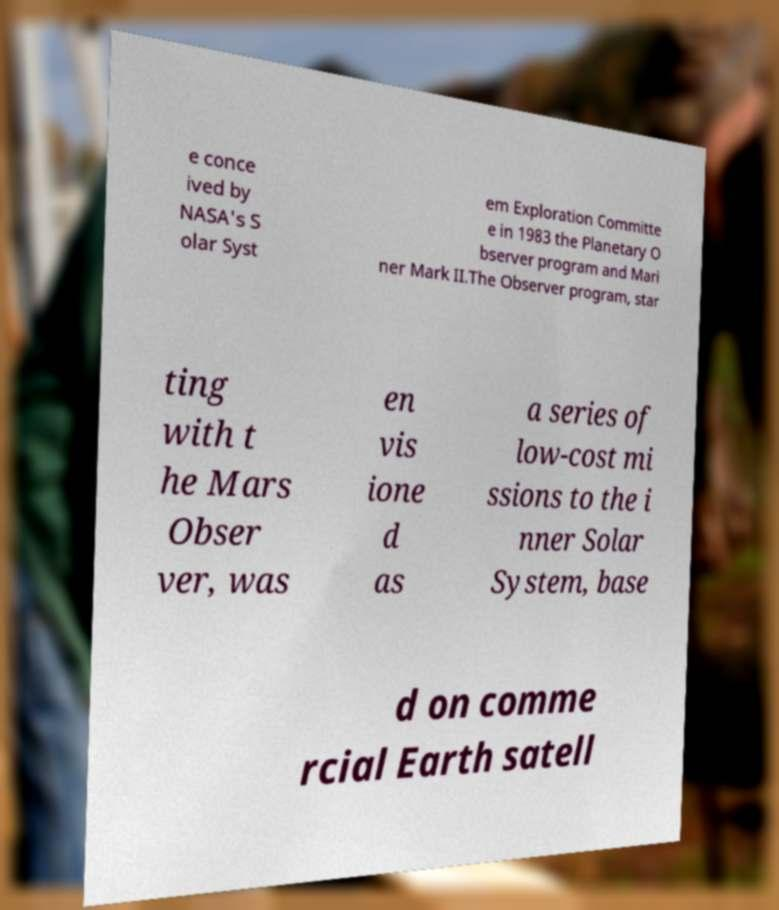There's text embedded in this image that I need extracted. Can you transcribe it verbatim? e conce ived by NASA's S olar Syst em Exploration Committe e in 1983 the Planetary O bserver program and Mari ner Mark II.The Observer program, star ting with t he Mars Obser ver, was en vis ione d as a series of low-cost mi ssions to the i nner Solar System, base d on comme rcial Earth satell 